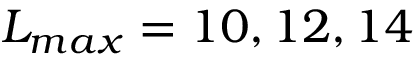Convert formula to latex. <formula><loc_0><loc_0><loc_500><loc_500>L _ { \max } = 1 0 , 1 2 , 1 4</formula> 